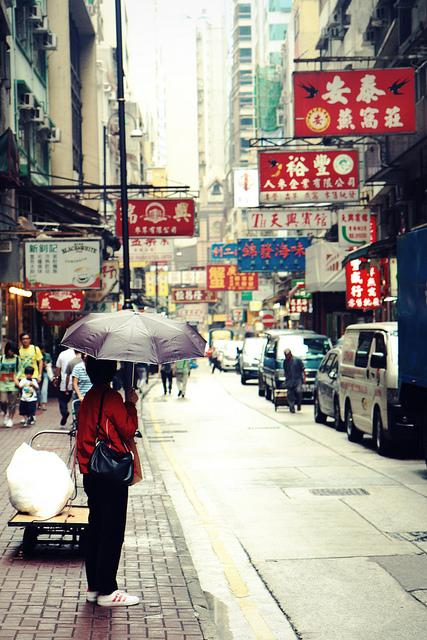Who is the maker of the white shoes?

Choices:
A) under armour
B) nike
C) adidas
D) new balance adidas 